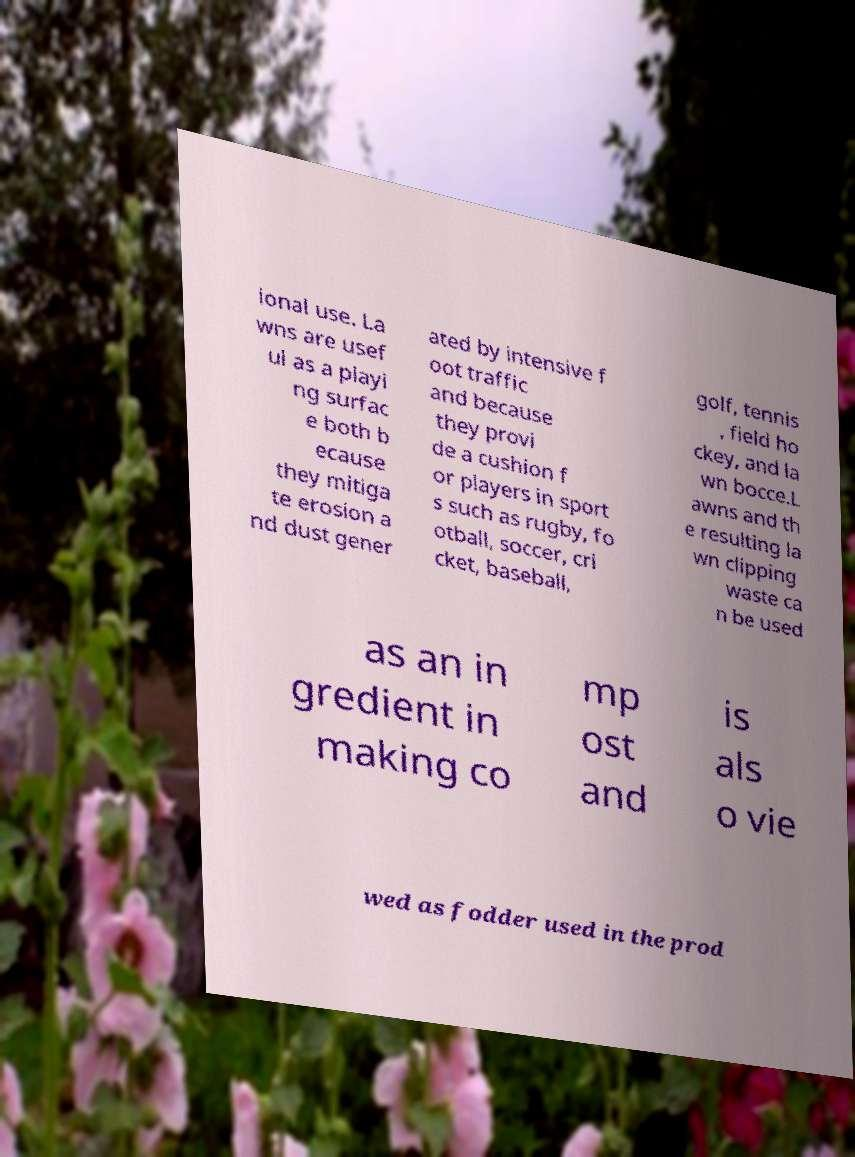There's text embedded in this image that I need extracted. Can you transcribe it verbatim? ional use. La wns are usef ul as a playi ng surfac e both b ecause they mitiga te erosion a nd dust gener ated by intensive f oot traffic and because they provi de a cushion f or players in sport s such as rugby, fo otball, soccer, cri cket, baseball, golf, tennis , field ho ckey, and la wn bocce.L awns and th e resulting la wn clipping waste ca n be used as an in gredient in making co mp ost and is als o vie wed as fodder used in the prod 